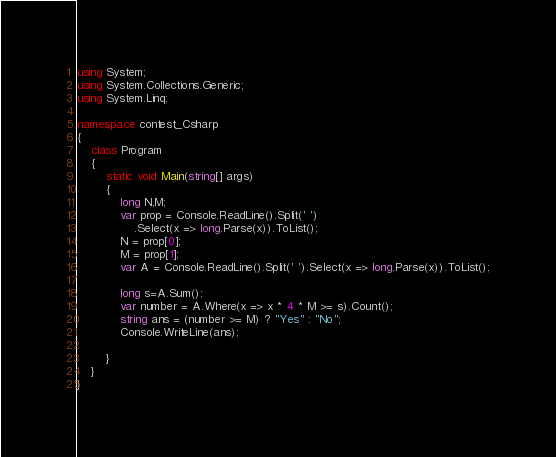Convert code to text. <code><loc_0><loc_0><loc_500><loc_500><_C#_>using System;
using System.Collections.Generic;
using System.Linq;

namespace contest_Csharp
{
    class Program
    {
        static void Main(string[] args)
        {
            long N,M;
            var prop = Console.ReadLine().Split(' ')
                .Select(x => long.Parse(x)).ToList();
            N = prop[0];
            M = prop[1];
            var A = Console.ReadLine().Split(' ').Select(x => long.Parse(x)).ToList();

            long s=A.Sum();
            var number = A.Where(x => x * 4 * M >= s).Count();
            string ans = (number >= M) ? "Yes" : "No";
            Console.WriteLine(ans);

        }
    }
}
</code> 